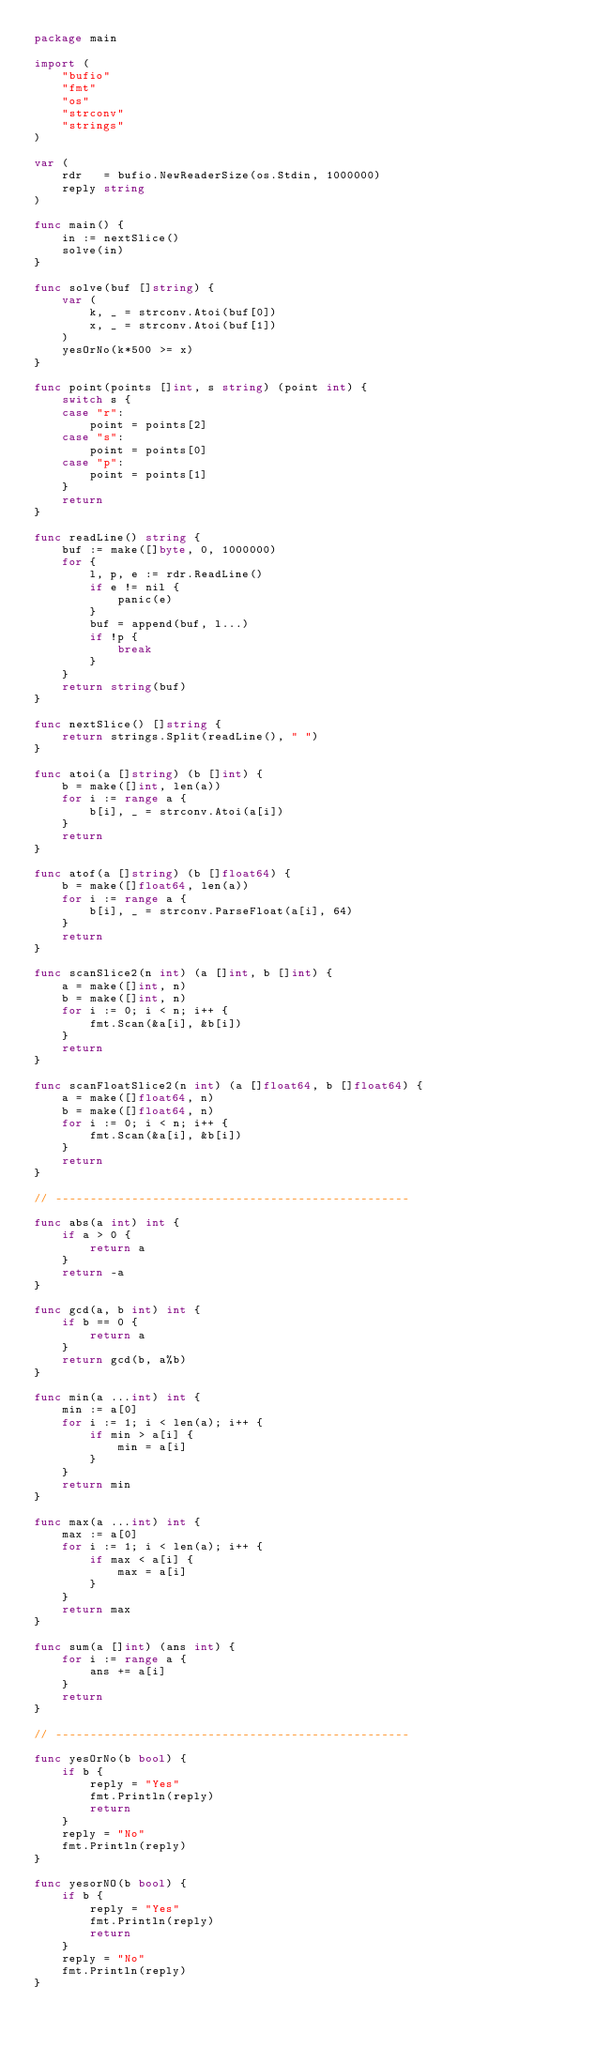Convert code to text. <code><loc_0><loc_0><loc_500><loc_500><_Go_>package main

import (
	"bufio"
	"fmt"
	"os"
	"strconv"
	"strings"
)

var (
	rdr   = bufio.NewReaderSize(os.Stdin, 1000000)
	reply string
)

func main() {
	in := nextSlice()
	solve(in)
}

func solve(buf []string) {
	var (
		k, _ = strconv.Atoi(buf[0])
		x, _ = strconv.Atoi(buf[1])
	)
	yesOrNo(k*500 >= x)
}

func point(points []int, s string) (point int) {
	switch s {
	case "r":
		point = points[2]
	case "s":
		point = points[0]
	case "p":
		point = points[1]
	}
	return
}

func readLine() string {
	buf := make([]byte, 0, 1000000)
	for {
		l, p, e := rdr.ReadLine()
		if e != nil {
			panic(e)
		}
		buf = append(buf, l...)
		if !p {
			break
		}
	}
	return string(buf)
}

func nextSlice() []string {
	return strings.Split(readLine(), " ")
}

func atoi(a []string) (b []int) {
	b = make([]int, len(a))
	for i := range a {
		b[i], _ = strconv.Atoi(a[i])
	}
	return
}

func atof(a []string) (b []float64) {
	b = make([]float64, len(a))
	for i := range a {
		b[i], _ = strconv.ParseFloat(a[i], 64)
	}
	return
}

func scanSlice2(n int) (a []int, b []int) {
	a = make([]int, n)
	b = make([]int, n)
	for i := 0; i < n; i++ {
		fmt.Scan(&a[i], &b[i])
	}
	return
}

func scanFloatSlice2(n int) (a []float64, b []float64) {
	a = make([]float64, n)
	b = make([]float64, n)
	for i := 0; i < n; i++ {
		fmt.Scan(&a[i], &b[i])
	}
	return
}

// ---------------------------------------------------

func abs(a int) int {
	if a > 0 {
		return a
	}
	return -a
}

func gcd(a, b int) int {
	if b == 0 {
		return a
	}
	return gcd(b, a%b)
}

func min(a ...int) int {
	min := a[0]
	for i := 1; i < len(a); i++ {
		if min > a[i] {
			min = a[i]
		}
	}
	return min
}

func max(a ...int) int {
	max := a[0]
	for i := 1; i < len(a); i++ {
		if max < a[i] {
			max = a[i]
		}
	}
	return max
}

func sum(a []int) (ans int) {
	for i := range a {
		ans += a[i]
	}
	return
}

// ---------------------------------------------------

func yesOrNo(b bool) {
	if b {
		reply = "Yes"
		fmt.Println(reply)
		return
	}
	reply = "No"
	fmt.Println(reply)
}

func yesorNO(b bool) {
	if b {
		reply = "Yes"
		fmt.Println(reply)
		return
	}
	reply = "No"
	fmt.Println(reply)
}</code> 